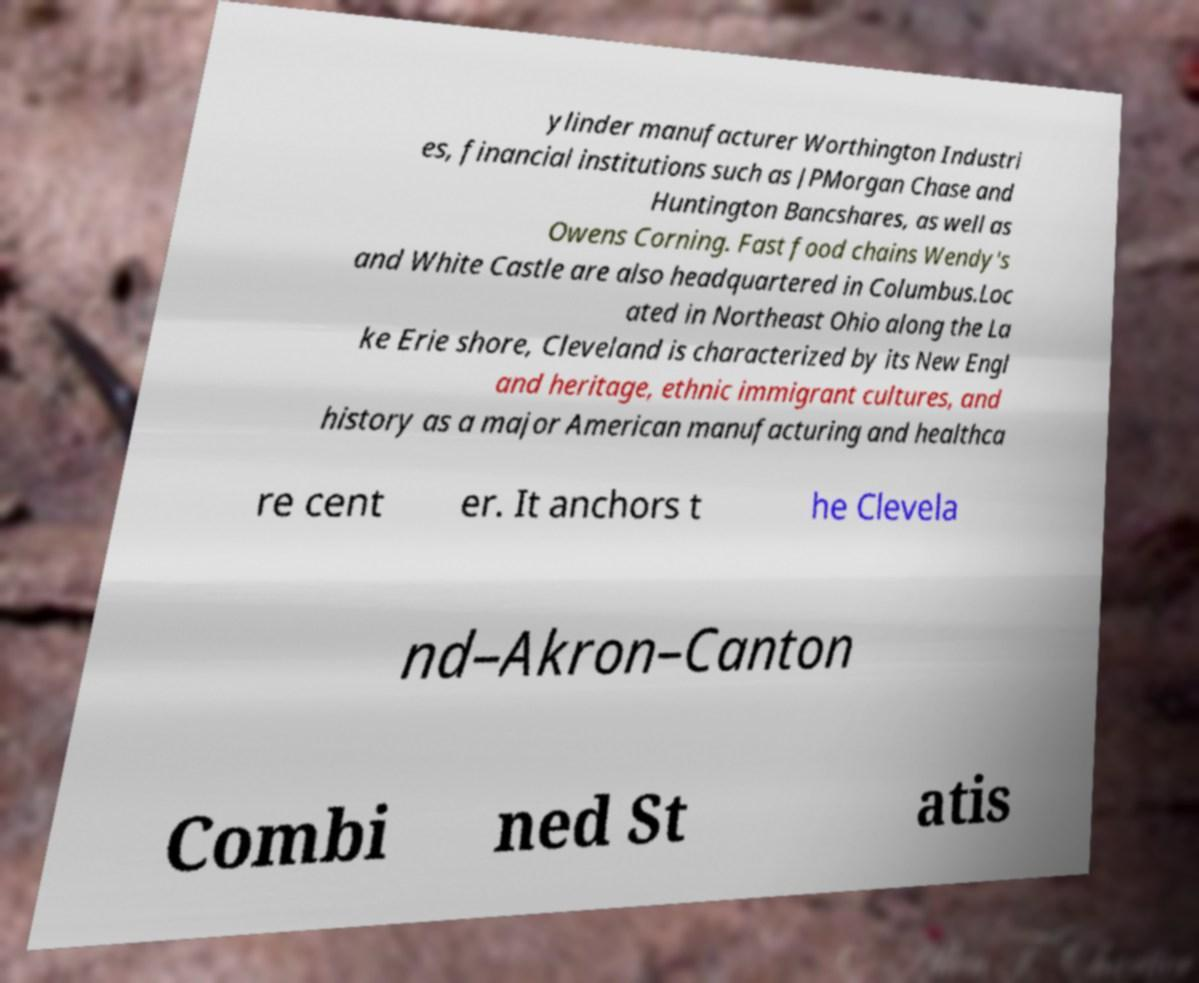Please read and relay the text visible in this image. What does it say? ylinder manufacturer Worthington Industri es, financial institutions such as JPMorgan Chase and Huntington Bancshares, as well as Owens Corning. Fast food chains Wendy's and White Castle are also headquartered in Columbus.Loc ated in Northeast Ohio along the La ke Erie shore, Cleveland is characterized by its New Engl and heritage, ethnic immigrant cultures, and history as a major American manufacturing and healthca re cent er. It anchors t he Clevela nd–Akron–Canton Combi ned St atis 